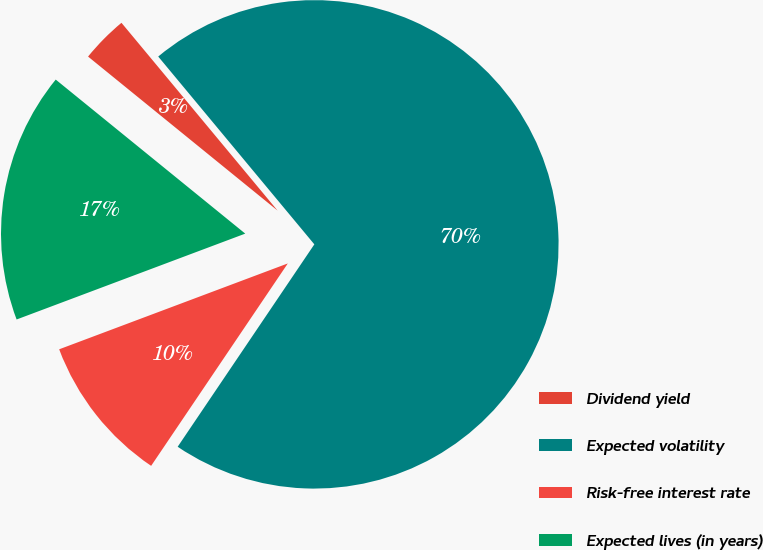<chart> <loc_0><loc_0><loc_500><loc_500><pie_chart><fcel>Dividend yield<fcel>Expected volatility<fcel>Risk-free interest rate<fcel>Expected lives (in years)<nl><fcel>3.1%<fcel>70.49%<fcel>9.83%<fcel>16.58%<nl></chart> 